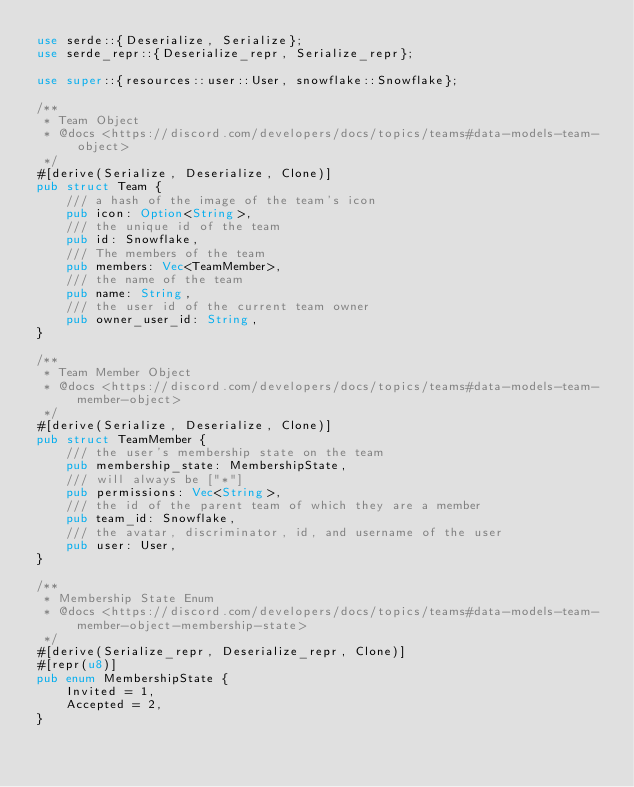<code> <loc_0><loc_0><loc_500><loc_500><_Rust_>use serde::{Deserialize, Serialize};
use serde_repr::{Deserialize_repr, Serialize_repr};

use super::{resources::user::User, snowflake::Snowflake};

/**
 * Team Object
 * @docs <https://discord.com/developers/docs/topics/teams#data-models-team-object>
 */
#[derive(Serialize, Deserialize, Clone)]
pub struct Team {
    /// a hash of the image of the team's icon
    pub icon: Option<String>,
    /// the unique id of the team
    pub id: Snowflake,
    /// The members of the team
    pub members: Vec<TeamMember>,
    /// the name of the team
    pub name: String,
    /// the user id of the current team owner
    pub owner_user_id: String,
}

/**
 * Team Member Object
 * @docs <https://discord.com/developers/docs/topics/teams#data-models-team-member-object>
 */
#[derive(Serialize, Deserialize, Clone)]
pub struct TeamMember {
    /// the user's membership state on the team
    pub membership_state: MembershipState,
    /// will always be ["*"]
    pub permissions: Vec<String>,
    /// the id of the parent team of which they are a member
    pub team_id: Snowflake,
    /// the avatar, discriminator, id, and username of the user
    pub user: User,
}

/**
 * Membership State Enum
 * @docs <https://discord.com/developers/docs/topics/teams#data-models-team-member-object-membership-state>
 */
#[derive(Serialize_repr, Deserialize_repr, Clone)]
#[repr(u8)]
pub enum MembershipState {
    Invited = 1,
    Accepted = 2,
}
</code> 